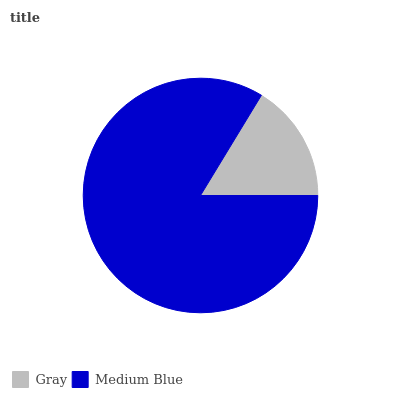Is Gray the minimum?
Answer yes or no. Yes. Is Medium Blue the maximum?
Answer yes or no. Yes. Is Medium Blue the minimum?
Answer yes or no. No. Is Medium Blue greater than Gray?
Answer yes or no. Yes. Is Gray less than Medium Blue?
Answer yes or no. Yes. Is Gray greater than Medium Blue?
Answer yes or no. No. Is Medium Blue less than Gray?
Answer yes or no. No. Is Medium Blue the high median?
Answer yes or no. Yes. Is Gray the low median?
Answer yes or no. Yes. Is Gray the high median?
Answer yes or no. No. Is Medium Blue the low median?
Answer yes or no. No. 